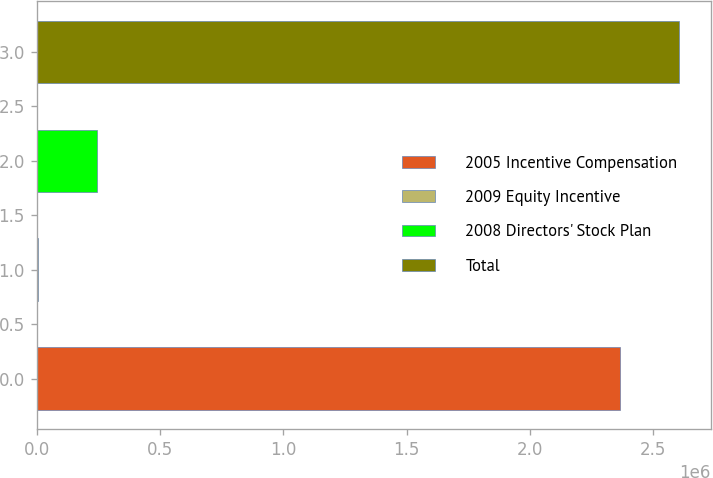Convert chart. <chart><loc_0><loc_0><loc_500><loc_500><bar_chart><fcel>2005 Incentive Compensation<fcel>2009 Equity Incentive<fcel>2008 Directors' Stock Plan<fcel>Total<nl><fcel>2.36358e+06<fcel>3700<fcel>243085<fcel>2.60297e+06<nl></chart> 